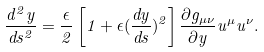<formula> <loc_0><loc_0><loc_500><loc_500>\frac { d ^ { 2 } y } { d s ^ { 2 } } = \frac { \epsilon } { 2 } \left [ 1 + \epsilon ( \frac { d y } { d s } ) ^ { 2 } \right ] \frac { \partial { g _ { \mu \nu } } } { \partial y } u ^ { \mu } u ^ { \nu } .</formula> 